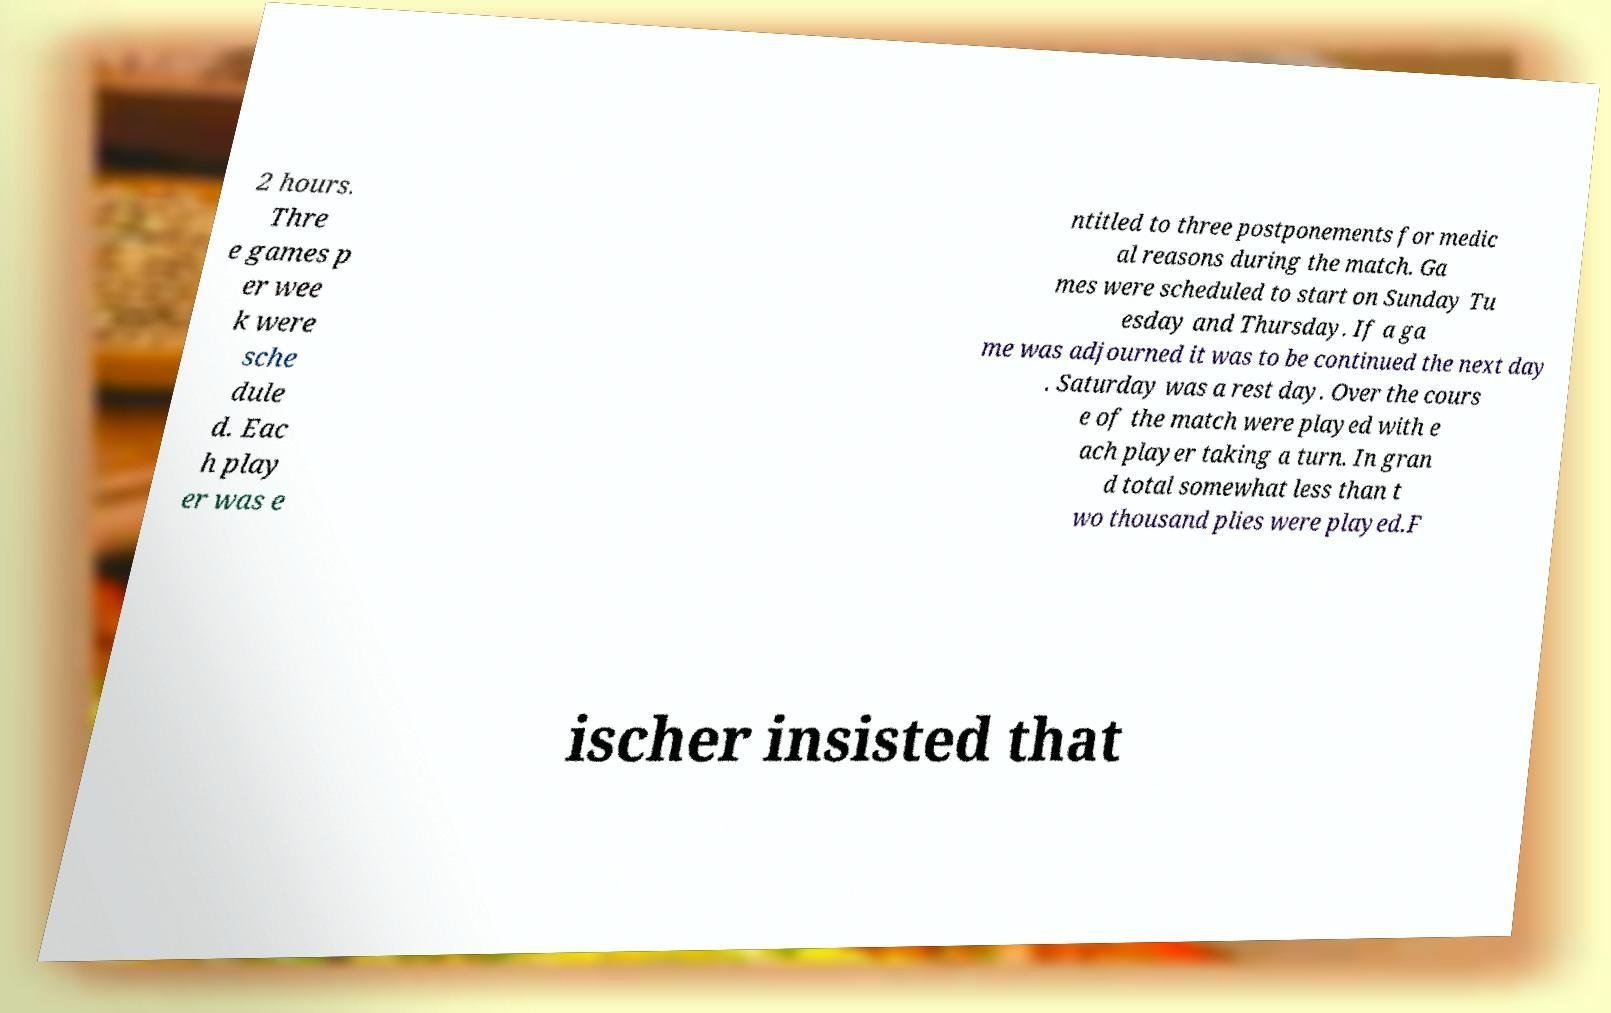Could you assist in decoding the text presented in this image and type it out clearly? 2 hours. Thre e games p er wee k were sche dule d. Eac h play er was e ntitled to three postponements for medic al reasons during the match. Ga mes were scheduled to start on Sunday Tu esday and Thursday. If a ga me was adjourned it was to be continued the next day . Saturday was a rest day. Over the cours e of the match were played with e ach player taking a turn. In gran d total somewhat less than t wo thousand plies were played.F ischer insisted that 